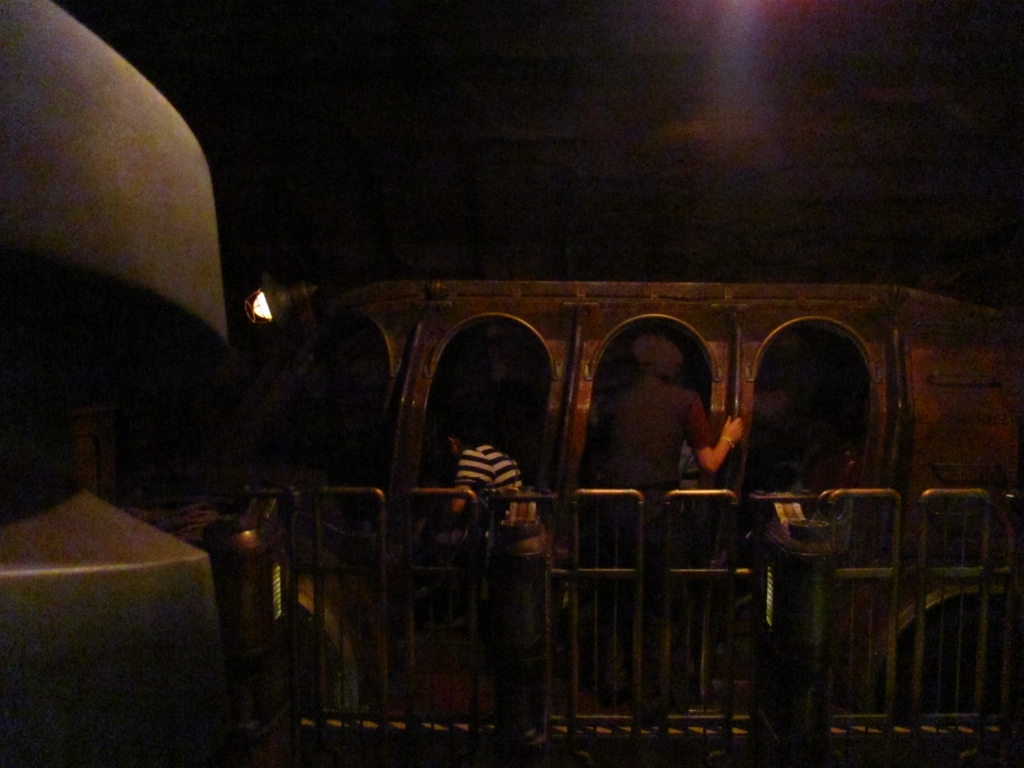The image is quite dark; can anything be done to enhance viewing? To enhance viewing, the image could be edited to adjust the brightness and contrast. This would help make the details more visible. Filters or photo editing software could be used to lighten the darker areas without overexposing the lighter ones, to better reveal the setting and the actions of any people or objects present. 